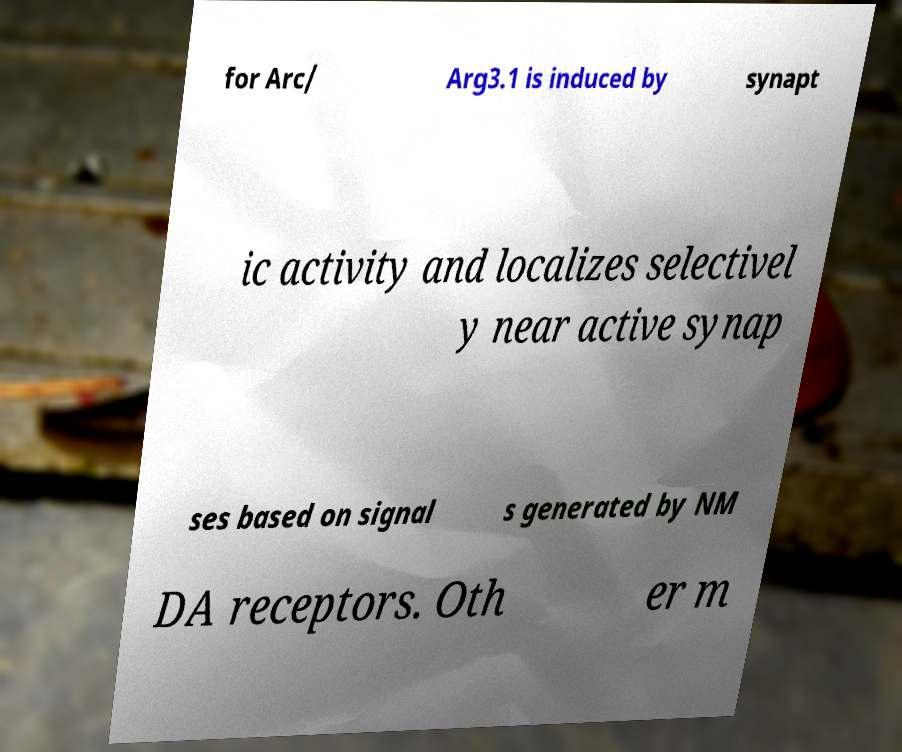What messages or text are displayed in this image? I need them in a readable, typed format. for Arc/ Arg3.1 is induced by synapt ic activity and localizes selectivel y near active synap ses based on signal s generated by NM DA receptors. Oth er m 